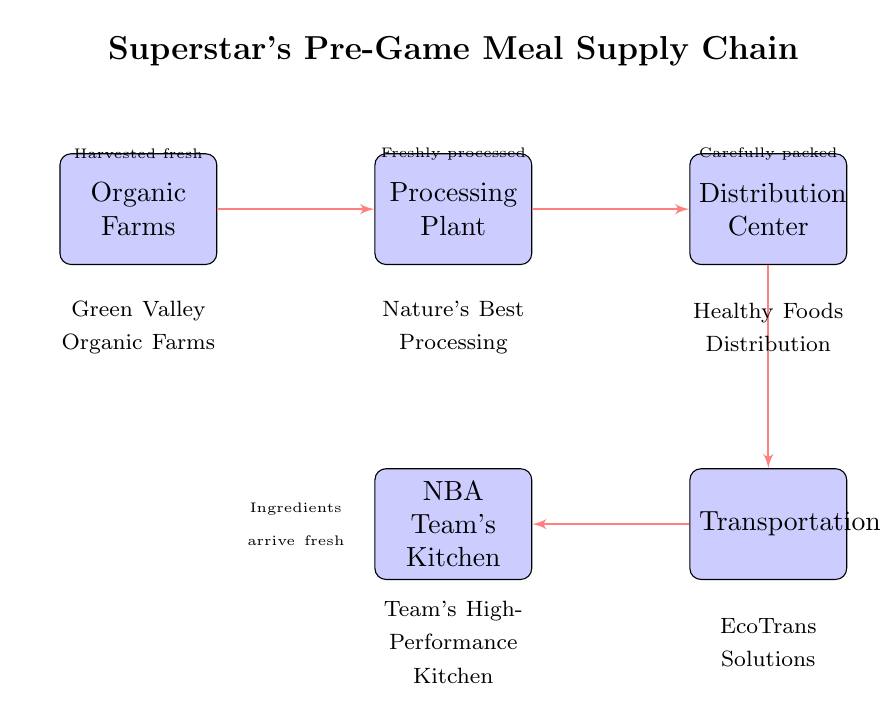What is the first node in the supply chain? The diagram indicates that the first node in the supply chain is the "Organic Farms." This is visually represented as the leftmost block in the diagram, making it the starting point of the chain.
Answer: Organic Farms How many nodes are there in the supply chain? By counting the blocks in the diagram, there are a total of five nodes: Organic Farms, Processing Plant, Distribution Center, Transportation, and NBA Team's Kitchen.
Answer: 5 What type of farm is represented at the start of the chart? The diagram specifies that the type of farm is "Organic Farms," which is detailed in the labeled block on the left side of the diagram.
Answer: Organic Which node comes immediately after the Processing Plant? The node that comes immediately after the Processing Plant is the "Distribution Center." This can be determined by following the arrows from the Processing Plant block to the next block in the sequence.
Answer: Distribution Center What is the last node in the supply chain? The last node in the supply chain is the "NBA Team's Kitchen," depicted as the rightmost block in the flow of the diagram.
Answer: NBA Team's Kitchen What is the relationship between the Distribution Center and Transportation? The relationship is indicated by an arrow, suggesting that there is a flow or connection from the Distribution Center to the Transportation node, implying that products are transported after distribution.
Answer: Flow/Connection What organization is responsible for processing the food in the supply chain? The organization responsible for processing the food is "Nature's Best Processing," indicated by the respective block that follows the farms in the diagram.
Answer: Nature's Best Processing What does the label above the Transportation node indicate? The label above the Transportation node states "Ingredients arrive fresh," indicating a key aspect of the supply chain's operational focus at this stage.
Answer: Ingredients arrive fresh What task occurs between the Organic Farms and the Processing Plant? The task that occurs between the Organic Farms and the Processing Plant is "Harvested fresh," as noted in the label above the Organic Farms block in the diagram.
Answer: Harvested fresh 